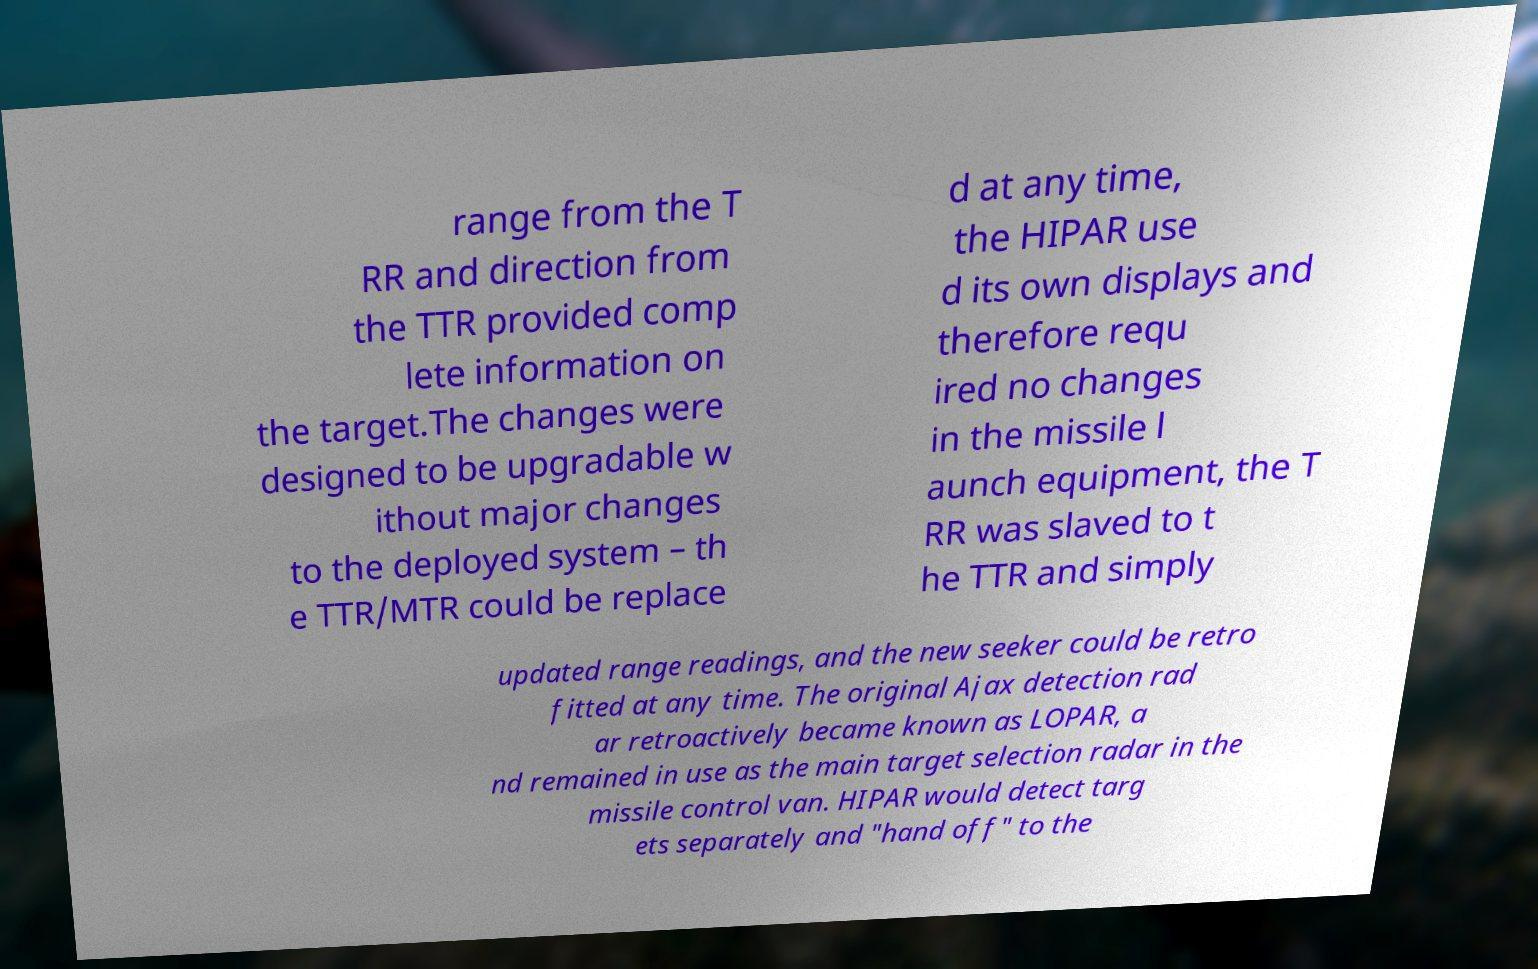There's text embedded in this image that I need extracted. Can you transcribe it verbatim? range from the T RR and direction from the TTR provided comp lete information on the target.The changes were designed to be upgradable w ithout major changes to the deployed system – th e TTR/MTR could be replace d at any time, the HIPAR use d its own displays and therefore requ ired no changes in the missile l aunch equipment, the T RR was slaved to t he TTR and simply updated range readings, and the new seeker could be retro fitted at any time. The original Ajax detection rad ar retroactively became known as LOPAR, a nd remained in use as the main target selection radar in the missile control van. HIPAR would detect targ ets separately and "hand off" to the 